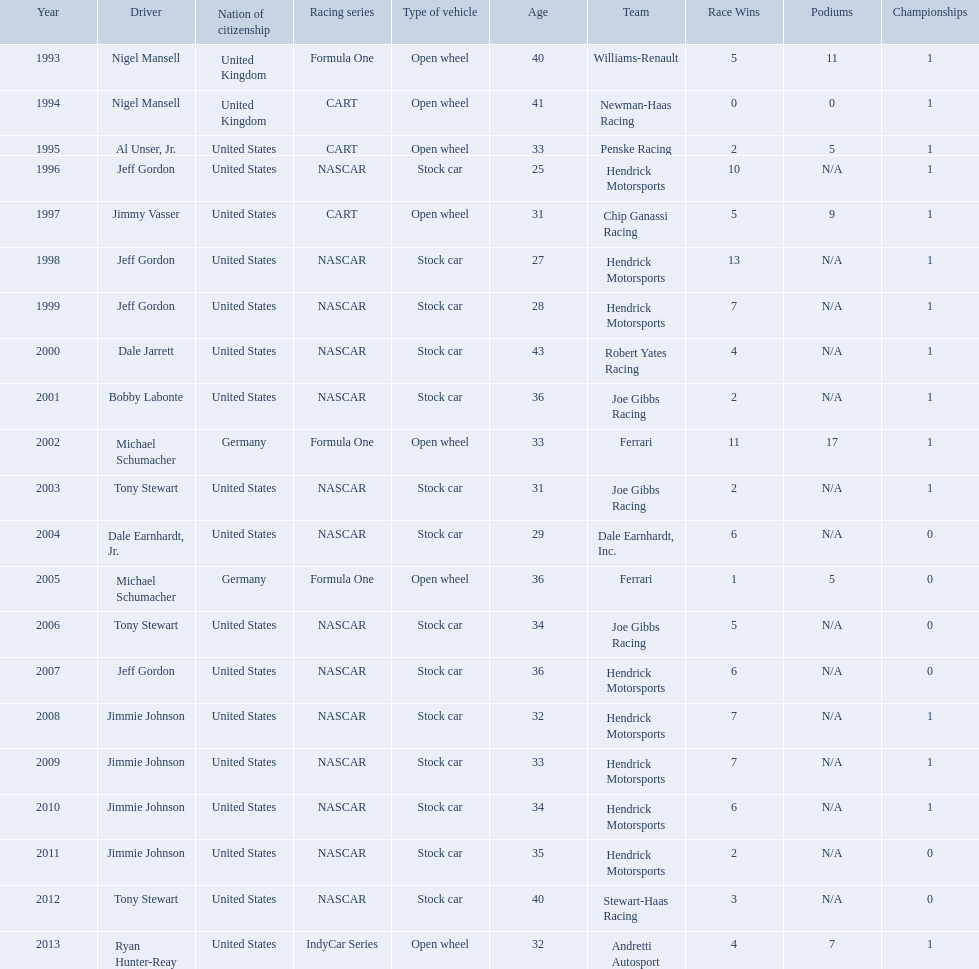Who won an espy in the year 2004, bobby labonte, tony stewart, dale earnhardt jr., or jeff gordon? Dale Earnhardt, Jr. Who won the espy in the year 1997; nigel mansell, al unser, jr., jeff gordon, or jimmy vasser? Jimmy Vasser. Which one only has one espy; nigel mansell, al unser jr., michael schumacher, or jeff gordon? Al Unser, Jr. What year(s) did nigel mansel receive epsy awards? 1993, 1994. What year(s) did michael schumacher receive epsy awards? 2002, 2005. What year(s) did jeff gordon receive epsy awards? 1996, 1998, 1999, 2007. What year(s) did al unser jr. receive epsy awards? 1995. Which driver only received one epsy award? Al Unser, Jr. 